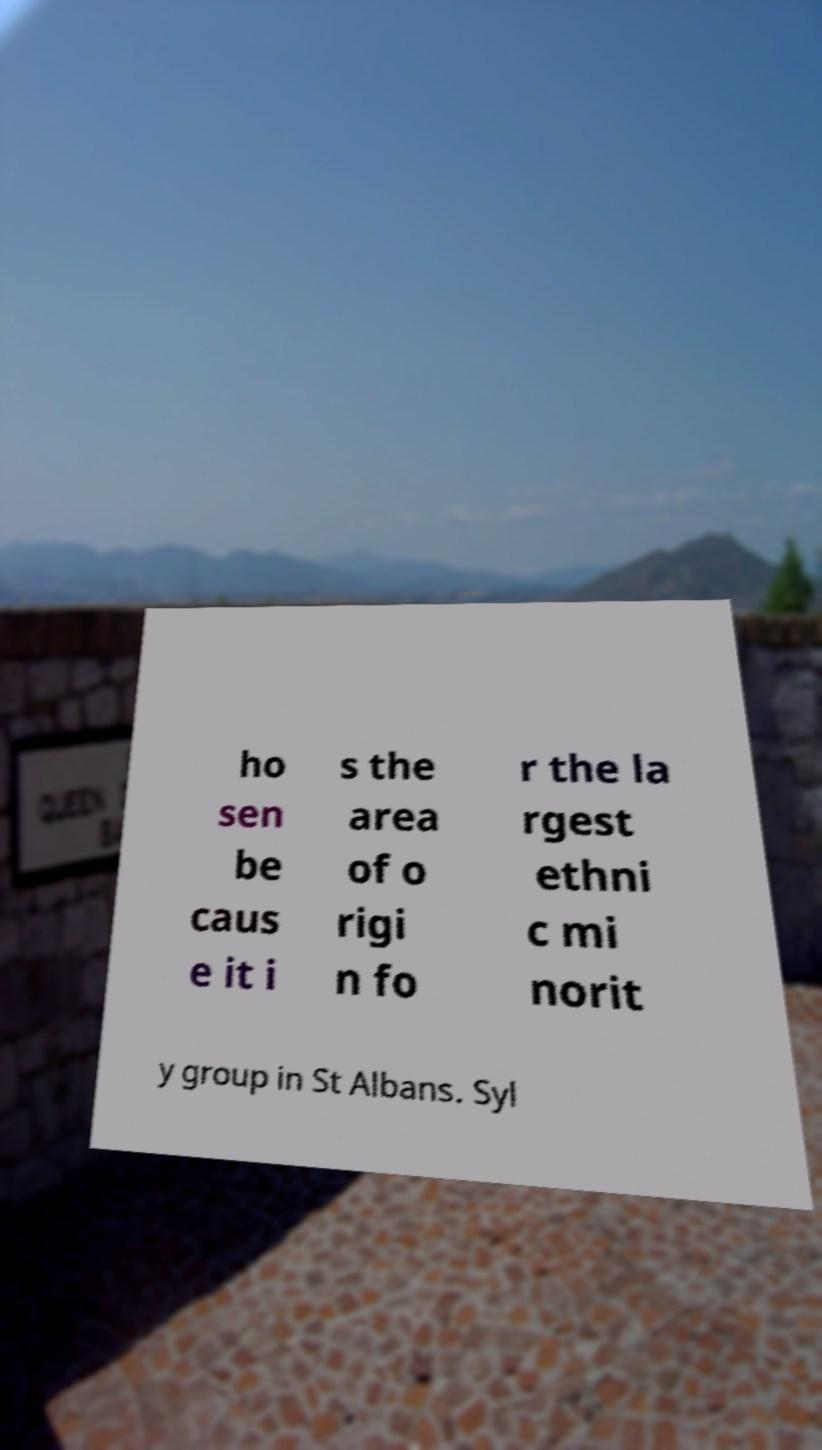Could you assist in decoding the text presented in this image and type it out clearly? ho sen be caus e it i s the area of o rigi n fo r the la rgest ethni c mi norit y group in St Albans. Syl 